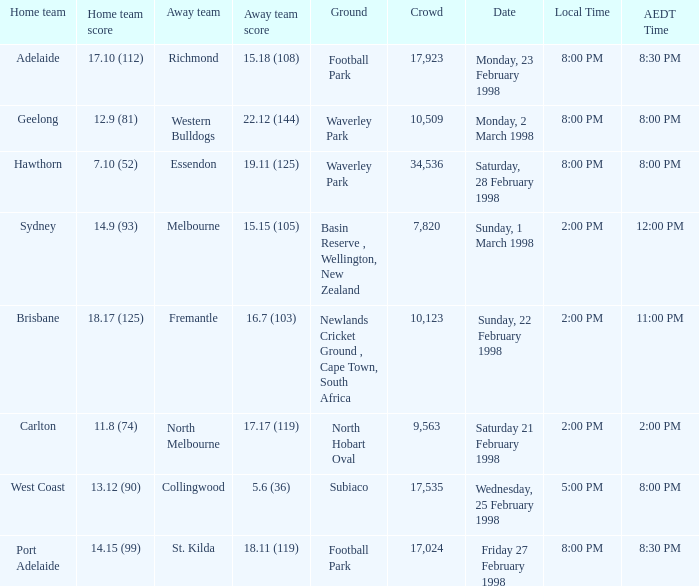Which Home team is on Wednesday, 25 february 1998? West Coast. 